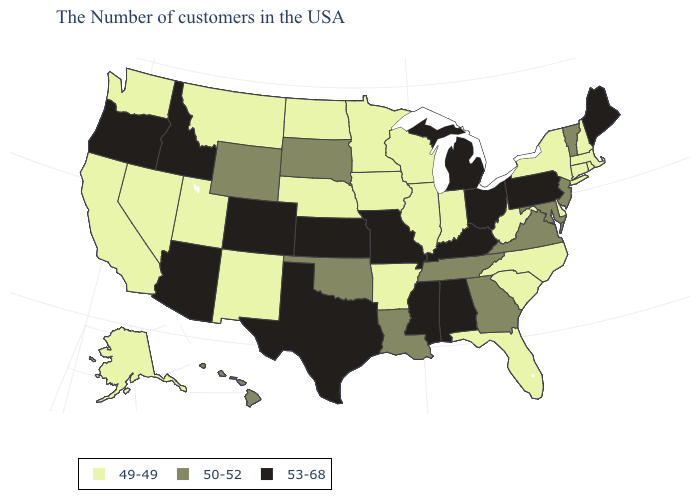Name the states that have a value in the range 49-49?
Quick response, please. Massachusetts, Rhode Island, New Hampshire, Connecticut, New York, Delaware, North Carolina, South Carolina, West Virginia, Florida, Indiana, Wisconsin, Illinois, Arkansas, Minnesota, Iowa, Nebraska, North Dakota, New Mexico, Utah, Montana, Nevada, California, Washington, Alaska. What is the value of Washington?
Write a very short answer. 49-49. What is the highest value in the West ?
Quick response, please. 53-68. Name the states that have a value in the range 50-52?
Short answer required. Vermont, New Jersey, Maryland, Virginia, Georgia, Tennessee, Louisiana, Oklahoma, South Dakota, Wyoming, Hawaii. What is the value of Colorado?
Give a very brief answer. 53-68. Name the states that have a value in the range 53-68?
Quick response, please. Maine, Pennsylvania, Ohio, Michigan, Kentucky, Alabama, Mississippi, Missouri, Kansas, Texas, Colorado, Arizona, Idaho, Oregon. Which states have the lowest value in the USA?
Write a very short answer. Massachusetts, Rhode Island, New Hampshire, Connecticut, New York, Delaware, North Carolina, South Carolina, West Virginia, Florida, Indiana, Wisconsin, Illinois, Arkansas, Minnesota, Iowa, Nebraska, North Dakota, New Mexico, Utah, Montana, Nevada, California, Washington, Alaska. What is the highest value in the South ?
Concise answer only. 53-68. Which states hav the highest value in the MidWest?
Concise answer only. Ohio, Michigan, Missouri, Kansas. Does Louisiana have a lower value than Oregon?
Concise answer only. Yes. Name the states that have a value in the range 53-68?
Concise answer only. Maine, Pennsylvania, Ohio, Michigan, Kentucky, Alabama, Mississippi, Missouri, Kansas, Texas, Colorado, Arizona, Idaho, Oregon. What is the value of New Jersey?
Give a very brief answer. 50-52. What is the lowest value in the West?
Give a very brief answer. 49-49. Does the first symbol in the legend represent the smallest category?
Give a very brief answer. Yes. Which states have the lowest value in the USA?
Quick response, please. Massachusetts, Rhode Island, New Hampshire, Connecticut, New York, Delaware, North Carolina, South Carolina, West Virginia, Florida, Indiana, Wisconsin, Illinois, Arkansas, Minnesota, Iowa, Nebraska, North Dakota, New Mexico, Utah, Montana, Nevada, California, Washington, Alaska. 